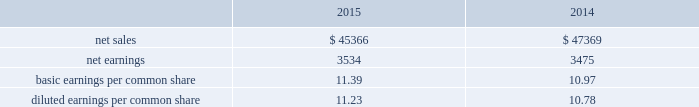The income approach indicates value for an asset or liability based on the present value of cash flow projected to be generated over the remaining economic life of the asset or liability being measured .
Both the amount and the duration of the cash flows are considered from a market participant perspective .
Our estimates of market participant net cash flows considered historical and projected pricing , remaining developmental effort , operational performance including company- specific synergies , aftermarket retention , product life cycles , material and labor pricing , and other relevant customer , contractual and market factors .
Where appropriate , the net cash flows are adjusted to reflect the uncertainties associated with the underlying assumptions , as well as the risk profile of the net cash flows utilized in the valuation .
The adjusted future cash flows are then discounted to present value using an appropriate discount rate .
Projected cash flow is discounted at a required rate of return that reflects the relative risk of achieving the cash flows and the time value of money .
The market approach is a valuation technique that uses prices and other relevant information generated by market transactions involving identical or comparable assets , liabilities , or a group of assets and liabilities .
Valuation techniques consistent with the market approach often use market multiples derived from a set of comparables .
The cost approach , which estimates value by determining the current cost of replacing an asset with another of equivalent economic utility , was used , as appropriate , for property , plant and equipment .
The cost to replace a given asset reflects the estimated reproduction or replacement cost , less an allowance for loss in value due to depreciation .
The purchase price allocation resulted in the recognition of $ 2.8 billion of goodwill , all of which is expected to be amortizable for tax purposes .
Substantially all of the goodwill was assigned to our rms business .
The goodwill recognized is attributable to expected revenue synergies generated by the integration of our products and technologies with those of sikorsky , costs synergies resulting from the consolidation or elimination of certain functions , and intangible assets that do not qualify for separate recognition , such as the assembled workforce of sikorsky .
Determining the fair value of assets acquired and liabilities assumed requires the exercise of significant judgments , including the amount and timing of expected future cash flows , long-term growth rates and discount rates .
The cash flows employed in the dcf analyses are based on our best estimate of future sales , earnings and cash flows after considering factors such as general market conditions , customer budgets , existing firm orders , expected future orders , contracts with suppliers , labor agreements , changes in working capital , long term business plans and recent operating performance .
Use of different estimates and judgments could yield different results .
Impact to 2015 financial results sikorsky 2019s 2015 financial results have been included in our consolidated financial results only for the period from the november 6 , 2015 acquisition date through december 31 , 2015 .
As a result , our consolidated financial results for the year ended december 31 , 2015 do not reflect a full year of sikorsky 2019s results .
From the november 6 , 2015 acquisition date through december 31 , 2015 , sikorsky generated net sales of approximately $ 400 million and operating loss of approximately $ 45 million , inclusive of intangible amortization and adjustments required to account for the acquisition .
We incurred approximately $ 38 million of non-recoverable transaction costs associated with the sikorsky acquisition in 2015 that were expensed as incurred .
These costs are included in other income , net on our consolidated statements of earnings .
We also incurred approximately $ 48 million in costs associated with issuing the $ 7.0 billion november 2015 notes used to repay all outstanding borrowings under the 364-day facility used to finance the acquisition .
The financing costs were recorded as a reduction of debt and will be amortized to interest expense over the term of the related debt .
Supplemental pro forma financial information ( unaudited ) the table presents summarized unaudited pro forma financial information as if sikorsky had been included in our financial results for the entire years in 2015 and 2014 ( in millions ) : .
The unaudited supplemental pro forma financial data above has been calculated after applying our accounting policies and adjusting the historical results of sikorsky with pro forma adjustments , net of tax , that assume the acquisition occurred on january 1 , 2014 .
Significant pro forma adjustments include the recognition of additional amortization expense related to acquired intangible assets and additional interest expense related to the short-term debt used to finance the acquisition .
These .
What is the net income margin for 2015? 
Computations: (3534 / 45366)
Answer: 0.0779. The income approach indicates value for an asset or liability based on the present value of cash flow projected to be generated over the remaining economic life of the asset or liability being measured .
Both the amount and the duration of the cash flows are considered from a market participant perspective .
Our estimates of market participant net cash flows considered historical and projected pricing , remaining developmental effort , operational performance including company- specific synergies , aftermarket retention , product life cycles , material and labor pricing , and other relevant customer , contractual and market factors .
Where appropriate , the net cash flows are adjusted to reflect the uncertainties associated with the underlying assumptions , as well as the risk profile of the net cash flows utilized in the valuation .
The adjusted future cash flows are then discounted to present value using an appropriate discount rate .
Projected cash flow is discounted at a required rate of return that reflects the relative risk of achieving the cash flows and the time value of money .
The market approach is a valuation technique that uses prices and other relevant information generated by market transactions involving identical or comparable assets , liabilities , or a group of assets and liabilities .
Valuation techniques consistent with the market approach often use market multiples derived from a set of comparables .
The cost approach , which estimates value by determining the current cost of replacing an asset with another of equivalent economic utility , was used , as appropriate , for property , plant and equipment .
The cost to replace a given asset reflects the estimated reproduction or replacement cost , less an allowance for loss in value due to depreciation .
The purchase price allocation resulted in the recognition of $ 2.8 billion of goodwill , all of which is expected to be amortizable for tax purposes .
Substantially all of the goodwill was assigned to our rms business .
The goodwill recognized is attributable to expected revenue synergies generated by the integration of our products and technologies with those of sikorsky , costs synergies resulting from the consolidation or elimination of certain functions , and intangible assets that do not qualify for separate recognition , such as the assembled workforce of sikorsky .
Determining the fair value of assets acquired and liabilities assumed requires the exercise of significant judgments , including the amount and timing of expected future cash flows , long-term growth rates and discount rates .
The cash flows employed in the dcf analyses are based on our best estimate of future sales , earnings and cash flows after considering factors such as general market conditions , customer budgets , existing firm orders , expected future orders , contracts with suppliers , labor agreements , changes in working capital , long term business plans and recent operating performance .
Use of different estimates and judgments could yield different results .
Impact to 2015 financial results sikorsky 2019s 2015 financial results have been included in our consolidated financial results only for the period from the november 6 , 2015 acquisition date through december 31 , 2015 .
As a result , our consolidated financial results for the year ended december 31 , 2015 do not reflect a full year of sikorsky 2019s results .
From the november 6 , 2015 acquisition date through december 31 , 2015 , sikorsky generated net sales of approximately $ 400 million and operating loss of approximately $ 45 million , inclusive of intangible amortization and adjustments required to account for the acquisition .
We incurred approximately $ 38 million of non-recoverable transaction costs associated with the sikorsky acquisition in 2015 that were expensed as incurred .
These costs are included in other income , net on our consolidated statements of earnings .
We also incurred approximately $ 48 million in costs associated with issuing the $ 7.0 billion november 2015 notes used to repay all outstanding borrowings under the 364-day facility used to finance the acquisition .
The financing costs were recorded as a reduction of debt and will be amortized to interest expense over the term of the related debt .
Supplemental pro forma financial information ( unaudited ) the table presents summarized unaudited pro forma financial information as if sikorsky had been included in our financial results for the entire years in 2015 and 2014 ( in millions ) : .
The unaudited supplemental pro forma financial data above has been calculated after applying our accounting policies and adjusting the historical results of sikorsky with pro forma adjustments , net of tax , that assume the acquisition occurred on january 1 , 2014 .
Significant pro forma adjustments include the recognition of additional amortization expense related to acquired intangible assets and additional interest expense related to the short-term debt used to finance the acquisition .
These .
What was the percentage change in net earnings from 2014 to 2015 for the pro forma financials? 
Computations: ((3534 - 3475) / 3475)
Answer: 0.01698. The income approach indicates value for an asset or liability based on the present value of cash flow projected to be generated over the remaining economic life of the asset or liability being measured .
Both the amount and the duration of the cash flows are considered from a market participant perspective .
Our estimates of market participant net cash flows considered historical and projected pricing , remaining developmental effort , operational performance including company- specific synergies , aftermarket retention , product life cycles , material and labor pricing , and other relevant customer , contractual and market factors .
Where appropriate , the net cash flows are adjusted to reflect the uncertainties associated with the underlying assumptions , as well as the risk profile of the net cash flows utilized in the valuation .
The adjusted future cash flows are then discounted to present value using an appropriate discount rate .
Projected cash flow is discounted at a required rate of return that reflects the relative risk of achieving the cash flows and the time value of money .
The market approach is a valuation technique that uses prices and other relevant information generated by market transactions involving identical or comparable assets , liabilities , or a group of assets and liabilities .
Valuation techniques consistent with the market approach often use market multiples derived from a set of comparables .
The cost approach , which estimates value by determining the current cost of replacing an asset with another of equivalent economic utility , was used , as appropriate , for property , plant and equipment .
The cost to replace a given asset reflects the estimated reproduction or replacement cost , less an allowance for loss in value due to depreciation .
The purchase price allocation resulted in the recognition of $ 2.8 billion of goodwill , all of which is expected to be amortizable for tax purposes .
Substantially all of the goodwill was assigned to our rms business .
The goodwill recognized is attributable to expected revenue synergies generated by the integration of our products and technologies with those of sikorsky , costs synergies resulting from the consolidation or elimination of certain functions , and intangible assets that do not qualify for separate recognition , such as the assembled workforce of sikorsky .
Determining the fair value of assets acquired and liabilities assumed requires the exercise of significant judgments , including the amount and timing of expected future cash flows , long-term growth rates and discount rates .
The cash flows employed in the dcf analyses are based on our best estimate of future sales , earnings and cash flows after considering factors such as general market conditions , customer budgets , existing firm orders , expected future orders , contracts with suppliers , labor agreements , changes in working capital , long term business plans and recent operating performance .
Use of different estimates and judgments could yield different results .
Impact to 2015 financial results sikorsky 2019s 2015 financial results have been included in our consolidated financial results only for the period from the november 6 , 2015 acquisition date through december 31 , 2015 .
As a result , our consolidated financial results for the year ended december 31 , 2015 do not reflect a full year of sikorsky 2019s results .
From the november 6 , 2015 acquisition date through december 31 , 2015 , sikorsky generated net sales of approximately $ 400 million and operating loss of approximately $ 45 million , inclusive of intangible amortization and adjustments required to account for the acquisition .
We incurred approximately $ 38 million of non-recoverable transaction costs associated with the sikorsky acquisition in 2015 that were expensed as incurred .
These costs are included in other income , net on our consolidated statements of earnings .
We also incurred approximately $ 48 million in costs associated with issuing the $ 7.0 billion november 2015 notes used to repay all outstanding borrowings under the 364-day facility used to finance the acquisition .
The financing costs were recorded as a reduction of debt and will be amortized to interest expense over the term of the related debt .
Supplemental pro forma financial information ( unaudited ) the table presents summarized unaudited pro forma financial information as if sikorsky had been included in our financial results for the entire years in 2015 and 2014 ( in millions ) : .
The unaudited supplemental pro forma financial data above has been calculated after applying our accounting policies and adjusting the historical results of sikorsky with pro forma adjustments , net of tax , that assume the acquisition occurred on january 1 , 2014 .
Significant pro forma adjustments include the recognition of additional amortization expense related to acquired intangible assets and additional interest expense related to the short-term debt used to finance the acquisition .
These .
What is the total number of common shares outstanding at the end of the year 2015 , ( in millions ) ? 
Computations: (3534 * 11.39)
Answer: 40252.26. 